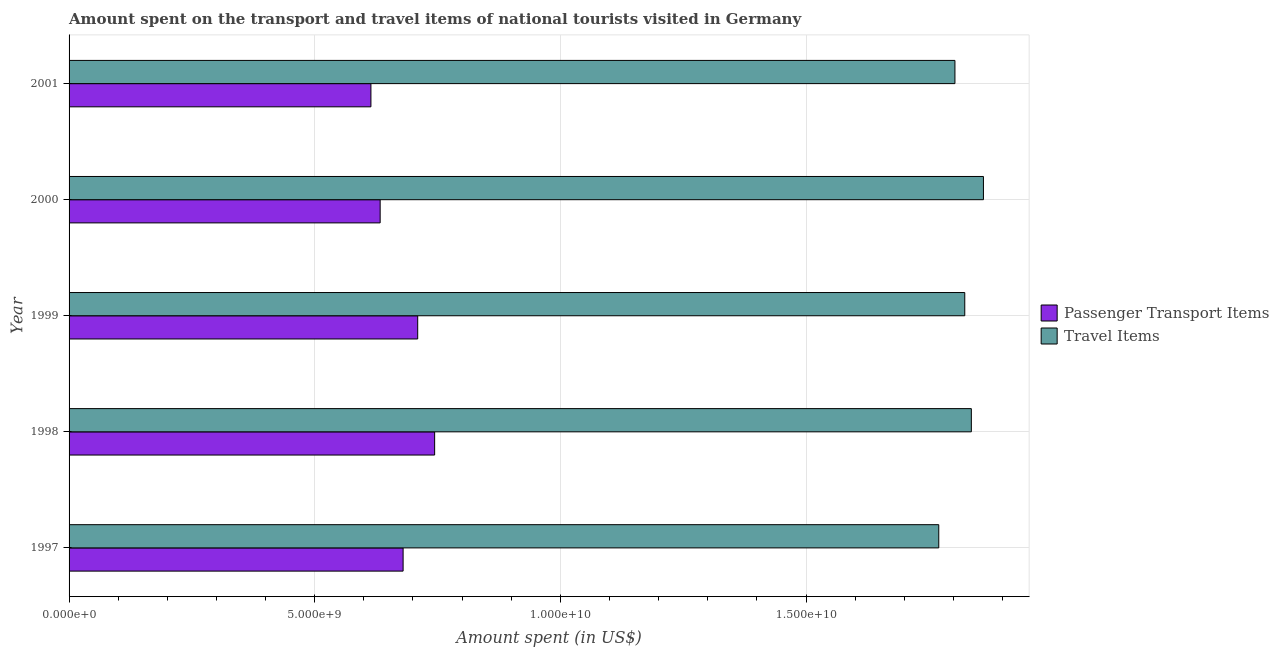How many groups of bars are there?
Provide a short and direct response. 5. What is the amount spent on passenger transport items in 1997?
Offer a very short reply. 6.80e+09. Across all years, what is the maximum amount spent in travel items?
Your answer should be compact. 1.86e+1. Across all years, what is the minimum amount spent on passenger transport items?
Make the answer very short. 6.14e+09. What is the total amount spent on passenger transport items in the graph?
Offer a terse response. 3.38e+1. What is the difference between the amount spent on passenger transport items in 1997 and that in 1999?
Provide a short and direct response. -2.97e+08. What is the difference between the amount spent on passenger transport items in 1997 and the amount spent in travel items in 2000?
Give a very brief answer. -1.18e+1. What is the average amount spent in travel items per year?
Your response must be concise. 1.82e+1. In the year 1998, what is the difference between the amount spent in travel items and amount spent on passenger transport items?
Make the answer very short. 1.09e+1. What is the ratio of the amount spent in travel items in 1998 to that in 1999?
Provide a succinct answer. 1.01. Is the amount spent on passenger transport items in 1997 less than that in 2000?
Provide a succinct answer. No. What is the difference between the highest and the second highest amount spent in travel items?
Offer a terse response. 2.46e+08. What is the difference between the highest and the lowest amount spent in travel items?
Your answer should be compact. 9.09e+08. Is the sum of the amount spent on passenger transport items in 1999 and 2001 greater than the maximum amount spent in travel items across all years?
Offer a terse response. No. What does the 2nd bar from the top in 1999 represents?
Keep it short and to the point. Passenger Transport Items. What does the 2nd bar from the bottom in 2001 represents?
Your answer should be very brief. Travel Items. How many bars are there?
Your answer should be very brief. 10. How many years are there in the graph?
Ensure brevity in your answer.  5. What is the difference between two consecutive major ticks on the X-axis?
Your answer should be compact. 5.00e+09. Are the values on the major ticks of X-axis written in scientific E-notation?
Offer a terse response. Yes. Does the graph contain grids?
Give a very brief answer. Yes. What is the title of the graph?
Keep it short and to the point. Amount spent on the transport and travel items of national tourists visited in Germany. What is the label or title of the X-axis?
Make the answer very short. Amount spent (in US$). What is the Amount spent (in US$) of Passenger Transport Items in 1997?
Provide a short and direct response. 6.80e+09. What is the Amount spent (in US$) in Travel Items in 1997?
Ensure brevity in your answer.  1.77e+1. What is the Amount spent (in US$) in Passenger Transport Items in 1998?
Ensure brevity in your answer.  7.44e+09. What is the Amount spent (in US$) in Travel Items in 1998?
Ensure brevity in your answer.  1.84e+1. What is the Amount spent (in US$) of Passenger Transport Items in 1999?
Your answer should be compact. 7.10e+09. What is the Amount spent (in US$) in Travel Items in 1999?
Provide a short and direct response. 1.82e+1. What is the Amount spent (in US$) of Passenger Transport Items in 2000?
Keep it short and to the point. 6.33e+09. What is the Amount spent (in US$) in Travel Items in 2000?
Make the answer very short. 1.86e+1. What is the Amount spent (in US$) in Passenger Transport Items in 2001?
Offer a very short reply. 6.14e+09. What is the Amount spent (in US$) in Travel Items in 2001?
Ensure brevity in your answer.  1.80e+1. Across all years, what is the maximum Amount spent (in US$) of Passenger Transport Items?
Give a very brief answer. 7.44e+09. Across all years, what is the maximum Amount spent (in US$) of Travel Items?
Ensure brevity in your answer.  1.86e+1. Across all years, what is the minimum Amount spent (in US$) in Passenger Transport Items?
Ensure brevity in your answer.  6.14e+09. Across all years, what is the minimum Amount spent (in US$) of Travel Items?
Ensure brevity in your answer.  1.77e+1. What is the total Amount spent (in US$) of Passenger Transport Items in the graph?
Your answer should be very brief. 3.38e+1. What is the total Amount spent (in US$) of Travel Items in the graph?
Make the answer very short. 9.09e+1. What is the difference between the Amount spent (in US$) of Passenger Transport Items in 1997 and that in 1998?
Offer a very short reply. -6.42e+08. What is the difference between the Amount spent (in US$) of Travel Items in 1997 and that in 1998?
Ensure brevity in your answer.  -6.63e+08. What is the difference between the Amount spent (in US$) in Passenger Transport Items in 1997 and that in 1999?
Keep it short and to the point. -2.97e+08. What is the difference between the Amount spent (in US$) of Travel Items in 1997 and that in 1999?
Your response must be concise. -5.29e+08. What is the difference between the Amount spent (in US$) of Passenger Transport Items in 1997 and that in 2000?
Offer a terse response. 4.67e+08. What is the difference between the Amount spent (in US$) of Travel Items in 1997 and that in 2000?
Your response must be concise. -9.09e+08. What is the difference between the Amount spent (in US$) in Passenger Transport Items in 1997 and that in 2001?
Your response must be concise. 6.55e+08. What is the difference between the Amount spent (in US$) in Travel Items in 1997 and that in 2001?
Your answer should be very brief. -3.29e+08. What is the difference between the Amount spent (in US$) in Passenger Transport Items in 1998 and that in 1999?
Your response must be concise. 3.45e+08. What is the difference between the Amount spent (in US$) in Travel Items in 1998 and that in 1999?
Ensure brevity in your answer.  1.34e+08. What is the difference between the Amount spent (in US$) of Passenger Transport Items in 1998 and that in 2000?
Offer a very short reply. 1.11e+09. What is the difference between the Amount spent (in US$) in Travel Items in 1998 and that in 2000?
Offer a terse response. -2.46e+08. What is the difference between the Amount spent (in US$) of Passenger Transport Items in 1998 and that in 2001?
Keep it short and to the point. 1.30e+09. What is the difference between the Amount spent (in US$) in Travel Items in 1998 and that in 2001?
Provide a succinct answer. 3.34e+08. What is the difference between the Amount spent (in US$) in Passenger Transport Items in 1999 and that in 2000?
Offer a terse response. 7.64e+08. What is the difference between the Amount spent (in US$) of Travel Items in 1999 and that in 2000?
Keep it short and to the point. -3.80e+08. What is the difference between the Amount spent (in US$) of Passenger Transport Items in 1999 and that in 2001?
Give a very brief answer. 9.52e+08. What is the difference between the Amount spent (in US$) of Passenger Transport Items in 2000 and that in 2001?
Provide a succinct answer. 1.88e+08. What is the difference between the Amount spent (in US$) of Travel Items in 2000 and that in 2001?
Provide a short and direct response. 5.80e+08. What is the difference between the Amount spent (in US$) in Passenger Transport Items in 1997 and the Amount spent (in US$) in Travel Items in 1998?
Provide a short and direct response. -1.16e+1. What is the difference between the Amount spent (in US$) of Passenger Transport Items in 1997 and the Amount spent (in US$) of Travel Items in 1999?
Offer a terse response. -1.14e+1. What is the difference between the Amount spent (in US$) of Passenger Transport Items in 1997 and the Amount spent (in US$) of Travel Items in 2000?
Your answer should be compact. -1.18e+1. What is the difference between the Amount spent (in US$) of Passenger Transport Items in 1997 and the Amount spent (in US$) of Travel Items in 2001?
Your response must be concise. -1.12e+1. What is the difference between the Amount spent (in US$) of Passenger Transport Items in 1998 and the Amount spent (in US$) of Travel Items in 1999?
Your answer should be compact. -1.08e+1. What is the difference between the Amount spent (in US$) in Passenger Transport Items in 1998 and the Amount spent (in US$) in Travel Items in 2000?
Your response must be concise. -1.12e+1. What is the difference between the Amount spent (in US$) in Passenger Transport Items in 1998 and the Amount spent (in US$) in Travel Items in 2001?
Keep it short and to the point. -1.06e+1. What is the difference between the Amount spent (in US$) of Passenger Transport Items in 1999 and the Amount spent (in US$) of Travel Items in 2000?
Your response must be concise. -1.15e+1. What is the difference between the Amount spent (in US$) in Passenger Transport Items in 1999 and the Amount spent (in US$) in Travel Items in 2001?
Offer a very short reply. -1.09e+1. What is the difference between the Amount spent (in US$) of Passenger Transport Items in 2000 and the Amount spent (in US$) of Travel Items in 2001?
Ensure brevity in your answer.  -1.17e+1. What is the average Amount spent (in US$) in Passenger Transport Items per year?
Make the answer very short. 6.76e+09. What is the average Amount spent (in US$) in Travel Items per year?
Ensure brevity in your answer.  1.82e+1. In the year 1997, what is the difference between the Amount spent (in US$) of Passenger Transport Items and Amount spent (in US$) of Travel Items?
Keep it short and to the point. -1.09e+1. In the year 1998, what is the difference between the Amount spent (in US$) of Passenger Transport Items and Amount spent (in US$) of Travel Items?
Give a very brief answer. -1.09e+1. In the year 1999, what is the difference between the Amount spent (in US$) of Passenger Transport Items and Amount spent (in US$) of Travel Items?
Your answer should be compact. -1.11e+1. In the year 2000, what is the difference between the Amount spent (in US$) of Passenger Transport Items and Amount spent (in US$) of Travel Items?
Offer a terse response. -1.23e+1. In the year 2001, what is the difference between the Amount spent (in US$) of Passenger Transport Items and Amount spent (in US$) of Travel Items?
Keep it short and to the point. -1.19e+1. What is the ratio of the Amount spent (in US$) in Passenger Transport Items in 1997 to that in 1998?
Your answer should be compact. 0.91. What is the ratio of the Amount spent (in US$) in Travel Items in 1997 to that in 1998?
Keep it short and to the point. 0.96. What is the ratio of the Amount spent (in US$) in Passenger Transport Items in 1997 to that in 1999?
Ensure brevity in your answer.  0.96. What is the ratio of the Amount spent (in US$) of Passenger Transport Items in 1997 to that in 2000?
Ensure brevity in your answer.  1.07. What is the ratio of the Amount spent (in US$) of Travel Items in 1997 to that in 2000?
Offer a very short reply. 0.95. What is the ratio of the Amount spent (in US$) of Passenger Transport Items in 1997 to that in 2001?
Offer a terse response. 1.11. What is the ratio of the Amount spent (in US$) in Travel Items in 1997 to that in 2001?
Keep it short and to the point. 0.98. What is the ratio of the Amount spent (in US$) in Passenger Transport Items in 1998 to that in 1999?
Make the answer very short. 1.05. What is the ratio of the Amount spent (in US$) of Travel Items in 1998 to that in 1999?
Keep it short and to the point. 1.01. What is the ratio of the Amount spent (in US$) of Passenger Transport Items in 1998 to that in 2000?
Ensure brevity in your answer.  1.18. What is the ratio of the Amount spent (in US$) of Passenger Transport Items in 1998 to that in 2001?
Your response must be concise. 1.21. What is the ratio of the Amount spent (in US$) of Travel Items in 1998 to that in 2001?
Provide a short and direct response. 1.02. What is the ratio of the Amount spent (in US$) in Passenger Transport Items in 1999 to that in 2000?
Your answer should be very brief. 1.12. What is the ratio of the Amount spent (in US$) of Travel Items in 1999 to that in 2000?
Provide a succinct answer. 0.98. What is the ratio of the Amount spent (in US$) in Passenger Transport Items in 1999 to that in 2001?
Provide a succinct answer. 1.15. What is the ratio of the Amount spent (in US$) of Travel Items in 1999 to that in 2001?
Your answer should be very brief. 1.01. What is the ratio of the Amount spent (in US$) in Passenger Transport Items in 2000 to that in 2001?
Give a very brief answer. 1.03. What is the ratio of the Amount spent (in US$) of Travel Items in 2000 to that in 2001?
Your response must be concise. 1.03. What is the difference between the highest and the second highest Amount spent (in US$) of Passenger Transport Items?
Offer a terse response. 3.45e+08. What is the difference between the highest and the second highest Amount spent (in US$) in Travel Items?
Provide a short and direct response. 2.46e+08. What is the difference between the highest and the lowest Amount spent (in US$) in Passenger Transport Items?
Offer a terse response. 1.30e+09. What is the difference between the highest and the lowest Amount spent (in US$) of Travel Items?
Your answer should be very brief. 9.09e+08. 